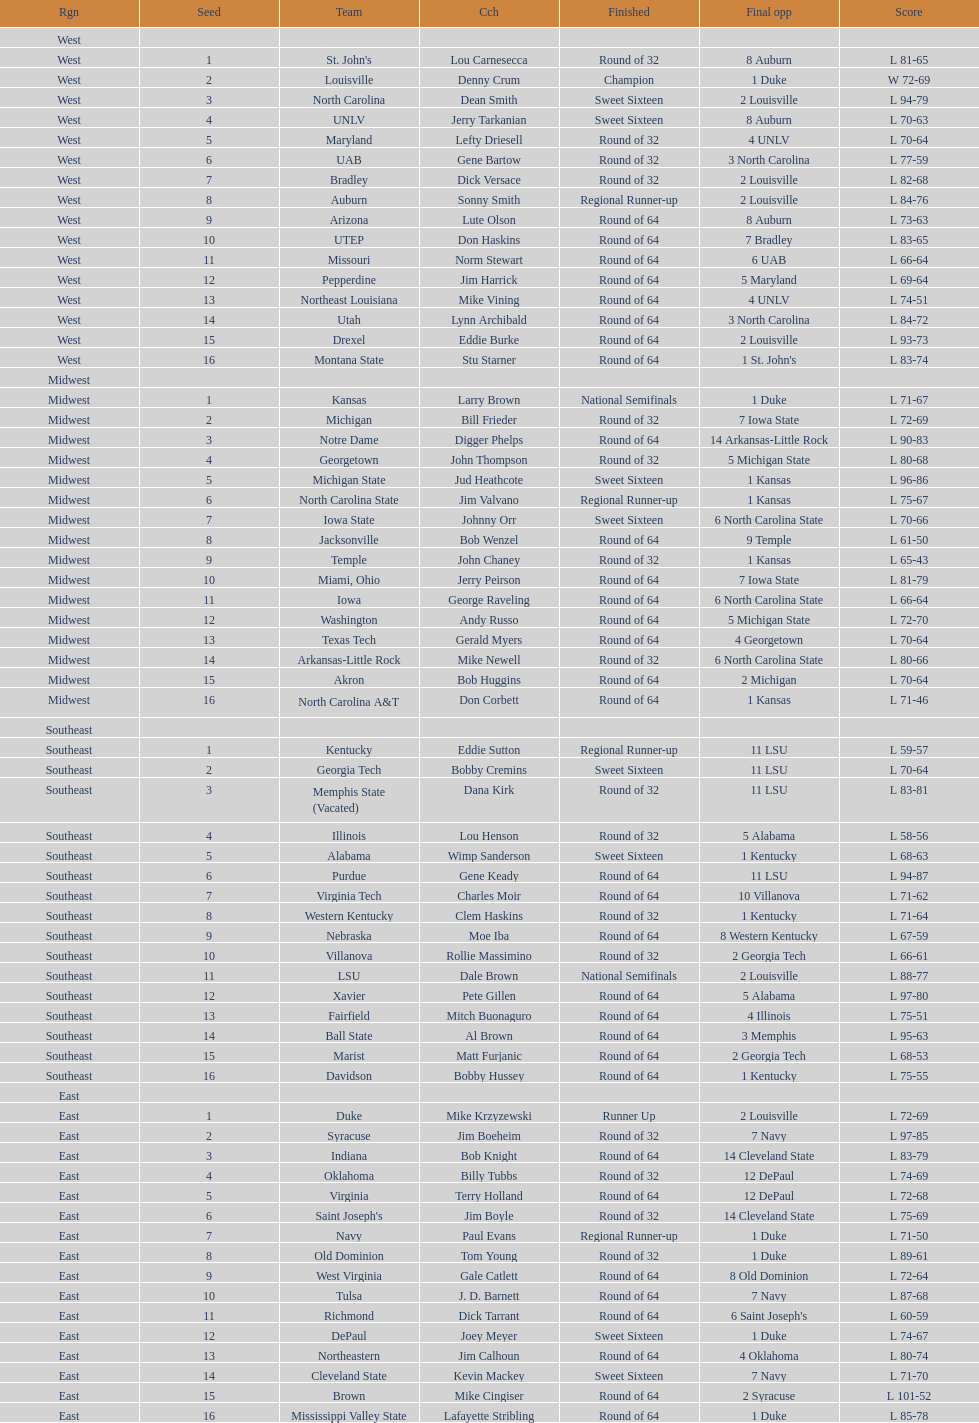What team finished at the top of all else and was finished as champions? Louisville. Could you parse the entire table? {'header': ['Rgn', 'Seed', 'Team', 'Cch', 'Finished', 'Final opp', 'Score'], 'rows': [['West', '', '', '', '', '', ''], ['West', '1', "St. John's", 'Lou Carnesecca', 'Round of 32', '8 Auburn', 'L 81-65'], ['West', '2', 'Louisville', 'Denny Crum', 'Champion', '1 Duke', 'W 72-69'], ['West', '3', 'North Carolina', 'Dean Smith', 'Sweet Sixteen', '2 Louisville', 'L 94-79'], ['West', '4', 'UNLV', 'Jerry Tarkanian', 'Sweet Sixteen', '8 Auburn', 'L 70-63'], ['West', '5', 'Maryland', 'Lefty Driesell', 'Round of 32', '4 UNLV', 'L 70-64'], ['West', '6', 'UAB', 'Gene Bartow', 'Round of 32', '3 North Carolina', 'L 77-59'], ['West', '7', 'Bradley', 'Dick Versace', 'Round of 32', '2 Louisville', 'L 82-68'], ['West', '8', 'Auburn', 'Sonny Smith', 'Regional Runner-up', '2 Louisville', 'L 84-76'], ['West', '9', 'Arizona', 'Lute Olson', 'Round of 64', '8 Auburn', 'L 73-63'], ['West', '10', 'UTEP', 'Don Haskins', 'Round of 64', '7 Bradley', 'L 83-65'], ['West', '11', 'Missouri', 'Norm Stewart', 'Round of 64', '6 UAB', 'L 66-64'], ['West', '12', 'Pepperdine', 'Jim Harrick', 'Round of 64', '5 Maryland', 'L 69-64'], ['West', '13', 'Northeast Louisiana', 'Mike Vining', 'Round of 64', '4 UNLV', 'L 74-51'], ['West', '14', 'Utah', 'Lynn Archibald', 'Round of 64', '3 North Carolina', 'L 84-72'], ['West', '15', 'Drexel', 'Eddie Burke', 'Round of 64', '2 Louisville', 'L 93-73'], ['West', '16', 'Montana State', 'Stu Starner', 'Round of 64', "1 St. John's", 'L 83-74'], ['Midwest', '', '', '', '', '', ''], ['Midwest', '1', 'Kansas', 'Larry Brown', 'National Semifinals', '1 Duke', 'L 71-67'], ['Midwest', '2', 'Michigan', 'Bill Frieder', 'Round of 32', '7 Iowa State', 'L 72-69'], ['Midwest', '3', 'Notre Dame', 'Digger Phelps', 'Round of 64', '14 Arkansas-Little Rock', 'L 90-83'], ['Midwest', '4', 'Georgetown', 'John Thompson', 'Round of 32', '5 Michigan State', 'L 80-68'], ['Midwest', '5', 'Michigan State', 'Jud Heathcote', 'Sweet Sixteen', '1 Kansas', 'L 96-86'], ['Midwest', '6', 'North Carolina State', 'Jim Valvano', 'Regional Runner-up', '1 Kansas', 'L 75-67'], ['Midwest', '7', 'Iowa State', 'Johnny Orr', 'Sweet Sixteen', '6 North Carolina State', 'L 70-66'], ['Midwest', '8', 'Jacksonville', 'Bob Wenzel', 'Round of 64', '9 Temple', 'L 61-50'], ['Midwest', '9', 'Temple', 'John Chaney', 'Round of 32', '1 Kansas', 'L 65-43'], ['Midwest', '10', 'Miami, Ohio', 'Jerry Peirson', 'Round of 64', '7 Iowa State', 'L 81-79'], ['Midwest', '11', 'Iowa', 'George Raveling', 'Round of 64', '6 North Carolina State', 'L 66-64'], ['Midwest', '12', 'Washington', 'Andy Russo', 'Round of 64', '5 Michigan State', 'L 72-70'], ['Midwest', '13', 'Texas Tech', 'Gerald Myers', 'Round of 64', '4 Georgetown', 'L 70-64'], ['Midwest', '14', 'Arkansas-Little Rock', 'Mike Newell', 'Round of 32', '6 North Carolina State', 'L 80-66'], ['Midwest', '15', 'Akron', 'Bob Huggins', 'Round of 64', '2 Michigan', 'L 70-64'], ['Midwest', '16', 'North Carolina A&T', 'Don Corbett', 'Round of 64', '1 Kansas', 'L 71-46'], ['Southeast', '', '', '', '', '', ''], ['Southeast', '1', 'Kentucky', 'Eddie Sutton', 'Regional Runner-up', '11 LSU', 'L 59-57'], ['Southeast', '2', 'Georgia Tech', 'Bobby Cremins', 'Sweet Sixteen', '11 LSU', 'L 70-64'], ['Southeast', '3', 'Memphis State (Vacated)', 'Dana Kirk', 'Round of 32', '11 LSU', 'L 83-81'], ['Southeast', '4', 'Illinois', 'Lou Henson', 'Round of 32', '5 Alabama', 'L 58-56'], ['Southeast', '5', 'Alabama', 'Wimp Sanderson', 'Sweet Sixteen', '1 Kentucky', 'L 68-63'], ['Southeast', '6', 'Purdue', 'Gene Keady', 'Round of 64', '11 LSU', 'L 94-87'], ['Southeast', '7', 'Virginia Tech', 'Charles Moir', 'Round of 64', '10 Villanova', 'L 71-62'], ['Southeast', '8', 'Western Kentucky', 'Clem Haskins', 'Round of 32', '1 Kentucky', 'L 71-64'], ['Southeast', '9', 'Nebraska', 'Moe Iba', 'Round of 64', '8 Western Kentucky', 'L 67-59'], ['Southeast', '10', 'Villanova', 'Rollie Massimino', 'Round of 32', '2 Georgia Tech', 'L 66-61'], ['Southeast', '11', 'LSU', 'Dale Brown', 'National Semifinals', '2 Louisville', 'L 88-77'], ['Southeast', '12', 'Xavier', 'Pete Gillen', 'Round of 64', '5 Alabama', 'L 97-80'], ['Southeast', '13', 'Fairfield', 'Mitch Buonaguro', 'Round of 64', '4 Illinois', 'L 75-51'], ['Southeast', '14', 'Ball State', 'Al Brown', 'Round of 64', '3 Memphis', 'L 95-63'], ['Southeast', '15', 'Marist', 'Matt Furjanic', 'Round of 64', '2 Georgia Tech', 'L 68-53'], ['Southeast', '16', 'Davidson', 'Bobby Hussey', 'Round of 64', '1 Kentucky', 'L 75-55'], ['East', '', '', '', '', '', ''], ['East', '1', 'Duke', 'Mike Krzyzewski', 'Runner Up', '2 Louisville', 'L 72-69'], ['East', '2', 'Syracuse', 'Jim Boeheim', 'Round of 32', '7 Navy', 'L 97-85'], ['East', '3', 'Indiana', 'Bob Knight', 'Round of 64', '14 Cleveland State', 'L 83-79'], ['East', '4', 'Oklahoma', 'Billy Tubbs', 'Round of 32', '12 DePaul', 'L 74-69'], ['East', '5', 'Virginia', 'Terry Holland', 'Round of 64', '12 DePaul', 'L 72-68'], ['East', '6', "Saint Joseph's", 'Jim Boyle', 'Round of 32', '14 Cleveland State', 'L 75-69'], ['East', '7', 'Navy', 'Paul Evans', 'Regional Runner-up', '1 Duke', 'L 71-50'], ['East', '8', 'Old Dominion', 'Tom Young', 'Round of 32', '1 Duke', 'L 89-61'], ['East', '9', 'West Virginia', 'Gale Catlett', 'Round of 64', '8 Old Dominion', 'L 72-64'], ['East', '10', 'Tulsa', 'J. D. Barnett', 'Round of 64', '7 Navy', 'L 87-68'], ['East', '11', 'Richmond', 'Dick Tarrant', 'Round of 64', "6 Saint Joseph's", 'L 60-59'], ['East', '12', 'DePaul', 'Joey Meyer', 'Sweet Sixteen', '1 Duke', 'L 74-67'], ['East', '13', 'Northeastern', 'Jim Calhoun', 'Round of 64', '4 Oklahoma', 'L 80-74'], ['East', '14', 'Cleveland State', 'Kevin Mackey', 'Sweet Sixteen', '7 Navy', 'L 71-70'], ['East', '15', 'Brown', 'Mike Cingiser', 'Round of 64', '2 Syracuse', 'L 101-52'], ['East', '16', 'Mississippi Valley State', 'Lafayette Stribling', 'Round of 64', '1 Duke', 'L 85-78']]} 